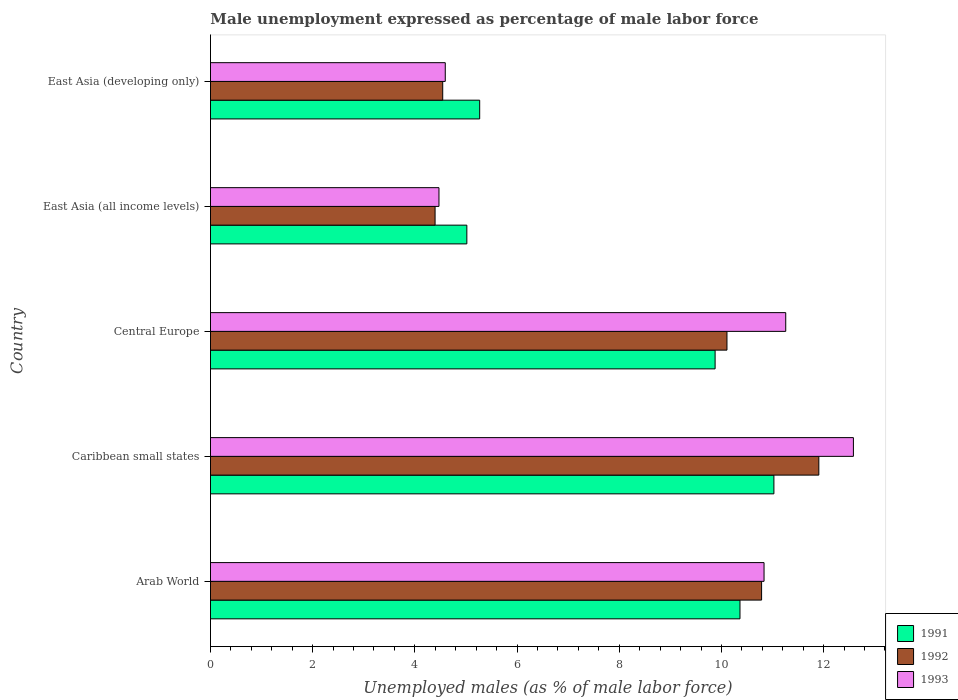Are the number of bars on each tick of the Y-axis equal?
Offer a very short reply. Yes. How many bars are there on the 4th tick from the top?
Give a very brief answer. 3. How many bars are there on the 4th tick from the bottom?
Ensure brevity in your answer.  3. What is the label of the 1st group of bars from the top?
Ensure brevity in your answer.  East Asia (developing only). What is the unemployment in males in in 1992 in East Asia (developing only)?
Provide a succinct answer. 4.55. Across all countries, what is the maximum unemployment in males in in 1992?
Provide a succinct answer. 11.91. Across all countries, what is the minimum unemployment in males in in 1992?
Your answer should be very brief. 4.4. In which country was the unemployment in males in in 1992 maximum?
Offer a very short reply. Caribbean small states. In which country was the unemployment in males in in 1991 minimum?
Make the answer very short. East Asia (all income levels). What is the total unemployment in males in in 1993 in the graph?
Your answer should be very brief. 43.74. What is the difference between the unemployment in males in in 1993 in Arab World and that in East Asia (all income levels)?
Provide a short and direct response. 6.36. What is the difference between the unemployment in males in in 1991 in Caribbean small states and the unemployment in males in in 1993 in East Asia (all income levels)?
Keep it short and to the point. 6.55. What is the average unemployment in males in in 1993 per country?
Offer a terse response. 8.75. What is the difference between the unemployment in males in in 1991 and unemployment in males in in 1992 in Arab World?
Offer a very short reply. -0.42. What is the ratio of the unemployment in males in in 1992 in Caribbean small states to that in East Asia (all income levels)?
Your answer should be very brief. 2.71. Is the difference between the unemployment in males in in 1991 in Arab World and Central Europe greater than the difference between the unemployment in males in in 1992 in Arab World and Central Europe?
Make the answer very short. No. What is the difference between the highest and the second highest unemployment in males in in 1993?
Your answer should be compact. 1.32. What is the difference between the highest and the lowest unemployment in males in in 1991?
Offer a terse response. 6.01. In how many countries, is the unemployment in males in in 1991 greater than the average unemployment in males in in 1991 taken over all countries?
Offer a terse response. 3. Is the sum of the unemployment in males in in 1991 in Caribbean small states and East Asia (all income levels) greater than the maximum unemployment in males in in 1992 across all countries?
Your answer should be compact. Yes. What is the difference between two consecutive major ticks on the X-axis?
Keep it short and to the point. 2. Does the graph contain grids?
Your response must be concise. No. What is the title of the graph?
Provide a succinct answer. Male unemployment expressed as percentage of male labor force. What is the label or title of the X-axis?
Ensure brevity in your answer.  Unemployed males (as % of male labor force). What is the Unemployed males (as % of male labor force) in 1991 in Arab World?
Make the answer very short. 10.36. What is the Unemployed males (as % of male labor force) of 1992 in Arab World?
Offer a terse response. 10.79. What is the Unemployed males (as % of male labor force) in 1993 in Arab World?
Ensure brevity in your answer.  10.83. What is the Unemployed males (as % of male labor force) of 1991 in Caribbean small states?
Give a very brief answer. 11.03. What is the Unemployed males (as % of male labor force) in 1992 in Caribbean small states?
Your answer should be very brief. 11.91. What is the Unemployed males (as % of male labor force) of 1993 in Caribbean small states?
Your answer should be very brief. 12.58. What is the Unemployed males (as % of male labor force) of 1991 in Central Europe?
Give a very brief answer. 9.88. What is the Unemployed males (as % of male labor force) in 1992 in Central Europe?
Ensure brevity in your answer.  10.11. What is the Unemployed males (as % of male labor force) in 1993 in Central Europe?
Provide a short and direct response. 11.26. What is the Unemployed males (as % of male labor force) of 1991 in East Asia (all income levels)?
Provide a succinct answer. 5.02. What is the Unemployed males (as % of male labor force) of 1992 in East Asia (all income levels)?
Your answer should be very brief. 4.4. What is the Unemployed males (as % of male labor force) of 1993 in East Asia (all income levels)?
Your answer should be very brief. 4.47. What is the Unemployed males (as % of male labor force) in 1991 in East Asia (developing only)?
Provide a succinct answer. 5.27. What is the Unemployed males (as % of male labor force) of 1992 in East Asia (developing only)?
Keep it short and to the point. 4.55. What is the Unemployed males (as % of male labor force) of 1993 in East Asia (developing only)?
Your answer should be very brief. 4.6. Across all countries, what is the maximum Unemployed males (as % of male labor force) in 1991?
Provide a short and direct response. 11.03. Across all countries, what is the maximum Unemployed males (as % of male labor force) of 1992?
Give a very brief answer. 11.91. Across all countries, what is the maximum Unemployed males (as % of male labor force) of 1993?
Offer a terse response. 12.58. Across all countries, what is the minimum Unemployed males (as % of male labor force) of 1991?
Your response must be concise. 5.02. Across all countries, what is the minimum Unemployed males (as % of male labor force) in 1992?
Offer a terse response. 4.4. Across all countries, what is the minimum Unemployed males (as % of male labor force) in 1993?
Make the answer very short. 4.47. What is the total Unemployed males (as % of male labor force) of 1991 in the graph?
Make the answer very short. 41.55. What is the total Unemployed males (as % of male labor force) in 1992 in the graph?
Ensure brevity in your answer.  41.74. What is the total Unemployed males (as % of male labor force) of 1993 in the graph?
Ensure brevity in your answer.  43.74. What is the difference between the Unemployed males (as % of male labor force) in 1991 in Arab World and that in Caribbean small states?
Offer a terse response. -0.66. What is the difference between the Unemployed males (as % of male labor force) of 1992 in Arab World and that in Caribbean small states?
Your answer should be very brief. -1.12. What is the difference between the Unemployed males (as % of male labor force) of 1993 in Arab World and that in Caribbean small states?
Provide a succinct answer. -1.75. What is the difference between the Unemployed males (as % of male labor force) of 1991 in Arab World and that in Central Europe?
Your answer should be compact. 0.49. What is the difference between the Unemployed males (as % of male labor force) of 1992 in Arab World and that in Central Europe?
Offer a very short reply. 0.68. What is the difference between the Unemployed males (as % of male labor force) in 1993 in Arab World and that in Central Europe?
Your answer should be very brief. -0.42. What is the difference between the Unemployed males (as % of male labor force) in 1991 in Arab World and that in East Asia (all income levels)?
Make the answer very short. 5.35. What is the difference between the Unemployed males (as % of male labor force) of 1992 in Arab World and that in East Asia (all income levels)?
Provide a short and direct response. 6.39. What is the difference between the Unemployed males (as % of male labor force) of 1993 in Arab World and that in East Asia (all income levels)?
Provide a succinct answer. 6.36. What is the difference between the Unemployed males (as % of male labor force) of 1991 in Arab World and that in East Asia (developing only)?
Offer a very short reply. 5.09. What is the difference between the Unemployed males (as % of male labor force) of 1992 in Arab World and that in East Asia (developing only)?
Ensure brevity in your answer.  6.24. What is the difference between the Unemployed males (as % of male labor force) of 1993 in Arab World and that in East Asia (developing only)?
Your answer should be compact. 6.24. What is the difference between the Unemployed males (as % of male labor force) of 1991 in Caribbean small states and that in Central Europe?
Offer a very short reply. 1.15. What is the difference between the Unemployed males (as % of male labor force) in 1992 in Caribbean small states and that in Central Europe?
Provide a short and direct response. 1.8. What is the difference between the Unemployed males (as % of male labor force) of 1993 in Caribbean small states and that in Central Europe?
Provide a short and direct response. 1.32. What is the difference between the Unemployed males (as % of male labor force) of 1991 in Caribbean small states and that in East Asia (all income levels)?
Ensure brevity in your answer.  6.01. What is the difference between the Unemployed males (as % of male labor force) of 1992 in Caribbean small states and that in East Asia (all income levels)?
Your answer should be very brief. 7.51. What is the difference between the Unemployed males (as % of male labor force) of 1993 in Caribbean small states and that in East Asia (all income levels)?
Make the answer very short. 8.11. What is the difference between the Unemployed males (as % of male labor force) in 1991 in Caribbean small states and that in East Asia (developing only)?
Your answer should be compact. 5.76. What is the difference between the Unemployed males (as % of male labor force) of 1992 in Caribbean small states and that in East Asia (developing only)?
Your answer should be very brief. 7.36. What is the difference between the Unemployed males (as % of male labor force) in 1993 in Caribbean small states and that in East Asia (developing only)?
Make the answer very short. 7.99. What is the difference between the Unemployed males (as % of male labor force) in 1991 in Central Europe and that in East Asia (all income levels)?
Provide a short and direct response. 4.86. What is the difference between the Unemployed males (as % of male labor force) of 1992 in Central Europe and that in East Asia (all income levels)?
Keep it short and to the point. 5.71. What is the difference between the Unemployed males (as % of male labor force) of 1993 in Central Europe and that in East Asia (all income levels)?
Provide a short and direct response. 6.79. What is the difference between the Unemployed males (as % of male labor force) in 1991 in Central Europe and that in East Asia (developing only)?
Offer a terse response. 4.61. What is the difference between the Unemployed males (as % of male labor force) in 1992 in Central Europe and that in East Asia (developing only)?
Your response must be concise. 5.56. What is the difference between the Unemployed males (as % of male labor force) of 1993 in Central Europe and that in East Asia (developing only)?
Provide a succinct answer. 6.66. What is the difference between the Unemployed males (as % of male labor force) in 1991 in East Asia (all income levels) and that in East Asia (developing only)?
Offer a terse response. -0.25. What is the difference between the Unemployed males (as % of male labor force) of 1992 in East Asia (all income levels) and that in East Asia (developing only)?
Offer a very short reply. -0.15. What is the difference between the Unemployed males (as % of male labor force) in 1993 in East Asia (all income levels) and that in East Asia (developing only)?
Your response must be concise. -0.12. What is the difference between the Unemployed males (as % of male labor force) in 1991 in Arab World and the Unemployed males (as % of male labor force) in 1992 in Caribbean small states?
Offer a very short reply. -1.54. What is the difference between the Unemployed males (as % of male labor force) in 1991 in Arab World and the Unemployed males (as % of male labor force) in 1993 in Caribbean small states?
Offer a terse response. -2.22. What is the difference between the Unemployed males (as % of male labor force) in 1992 in Arab World and the Unemployed males (as % of male labor force) in 1993 in Caribbean small states?
Your response must be concise. -1.8. What is the difference between the Unemployed males (as % of male labor force) in 1991 in Arab World and the Unemployed males (as % of male labor force) in 1992 in Central Europe?
Your response must be concise. 0.25. What is the difference between the Unemployed males (as % of male labor force) of 1991 in Arab World and the Unemployed males (as % of male labor force) of 1993 in Central Europe?
Your answer should be compact. -0.9. What is the difference between the Unemployed males (as % of male labor force) in 1992 in Arab World and the Unemployed males (as % of male labor force) in 1993 in Central Europe?
Your answer should be compact. -0.47. What is the difference between the Unemployed males (as % of male labor force) in 1991 in Arab World and the Unemployed males (as % of male labor force) in 1992 in East Asia (all income levels)?
Give a very brief answer. 5.97. What is the difference between the Unemployed males (as % of male labor force) in 1991 in Arab World and the Unemployed males (as % of male labor force) in 1993 in East Asia (all income levels)?
Your answer should be very brief. 5.89. What is the difference between the Unemployed males (as % of male labor force) in 1992 in Arab World and the Unemployed males (as % of male labor force) in 1993 in East Asia (all income levels)?
Give a very brief answer. 6.31. What is the difference between the Unemployed males (as % of male labor force) in 1991 in Arab World and the Unemployed males (as % of male labor force) in 1992 in East Asia (developing only)?
Provide a short and direct response. 5.82. What is the difference between the Unemployed males (as % of male labor force) in 1991 in Arab World and the Unemployed males (as % of male labor force) in 1993 in East Asia (developing only)?
Give a very brief answer. 5.77. What is the difference between the Unemployed males (as % of male labor force) in 1992 in Arab World and the Unemployed males (as % of male labor force) in 1993 in East Asia (developing only)?
Your response must be concise. 6.19. What is the difference between the Unemployed males (as % of male labor force) of 1991 in Caribbean small states and the Unemployed males (as % of male labor force) of 1992 in Central Europe?
Provide a succinct answer. 0.92. What is the difference between the Unemployed males (as % of male labor force) of 1991 in Caribbean small states and the Unemployed males (as % of male labor force) of 1993 in Central Europe?
Keep it short and to the point. -0.23. What is the difference between the Unemployed males (as % of male labor force) in 1992 in Caribbean small states and the Unemployed males (as % of male labor force) in 1993 in Central Europe?
Provide a short and direct response. 0.65. What is the difference between the Unemployed males (as % of male labor force) in 1991 in Caribbean small states and the Unemployed males (as % of male labor force) in 1992 in East Asia (all income levels)?
Your response must be concise. 6.63. What is the difference between the Unemployed males (as % of male labor force) in 1991 in Caribbean small states and the Unemployed males (as % of male labor force) in 1993 in East Asia (all income levels)?
Give a very brief answer. 6.55. What is the difference between the Unemployed males (as % of male labor force) of 1992 in Caribbean small states and the Unemployed males (as % of male labor force) of 1993 in East Asia (all income levels)?
Your response must be concise. 7.43. What is the difference between the Unemployed males (as % of male labor force) of 1991 in Caribbean small states and the Unemployed males (as % of male labor force) of 1992 in East Asia (developing only)?
Provide a short and direct response. 6.48. What is the difference between the Unemployed males (as % of male labor force) of 1991 in Caribbean small states and the Unemployed males (as % of male labor force) of 1993 in East Asia (developing only)?
Offer a very short reply. 6.43. What is the difference between the Unemployed males (as % of male labor force) in 1992 in Caribbean small states and the Unemployed males (as % of male labor force) in 1993 in East Asia (developing only)?
Give a very brief answer. 7.31. What is the difference between the Unemployed males (as % of male labor force) in 1991 in Central Europe and the Unemployed males (as % of male labor force) in 1992 in East Asia (all income levels)?
Ensure brevity in your answer.  5.48. What is the difference between the Unemployed males (as % of male labor force) of 1991 in Central Europe and the Unemployed males (as % of male labor force) of 1993 in East Asia (all income levels)?
Offer a very short reply. 5.4. What is the difference between the Unemployed males (as % of male labor force) of 1992 in Central Europe and the Unemployed males (as % of male labor force) of 1993 in East Asia (all income levels)?
Your answer should be compact. 5.64. What is the difference between the Unemployed males (as % of male labor force) in 1991 in Central Europe and the Unemployed males (as % of male labor force) in 1992 in East Asia (developing only)?
Keep it short and to the point. 5.33. What is the difference between the Unemployed males (as % of male labor force) in 1991 in Central Europe and the Unemployed males (as % of male labor force) in 1993 in East Asia (developing only)?
Offer a very short reply. 5.28. What is the difference between the Unemployed males (as % of male labor force) in 1992 in Central Europe and the Unemployed males (as % of male labor force) in 1993 in East Asia (developing only)?
Your answer should be very brief. 5.51. What is the difference between the Unemployed males (as % of male labor force) of 1991 in East Asia (all income levels) and the Unemployed males (as % of male labor force) of 1992 in East Asia (developing only)?
Make the answer very short. 0.47. What is the difference between the Unemployed males (as % of male labor force) of 1991 in East Asia (all income levels) and the Unemployed males (as % of male labor force) of 1993 in East Asia (developing only)?
Your answer should be compact. 0.42. What is the difference between the Unemployed males (as % of male labor force) in 1992 in East Asia (all income levels) and the Unemployed males (as % of male labor force) in 1993 in East Asia (developing only)?
Provide a short and direct response. -0.2. What is the average Unemployed males (as % of male labor force) of 1991 per country?
Give a very brief answer. 8.31. What is the average Unemployed males (as % of male labor force) in 1992 per country?
Your answer should be compact. 8.35. What is the average Unemployed males (as % of male labor force) in 1993 per country?
Offer a terse response. 8.75. What is the difference between the Unemployed males (as % of male labor force) in 1991 and Unemployed males (as % of male labor force) in 1992 in Arab World?
Offer a very short reply. -0.42. What is the difference between the Unemployed males (as % of male labor force) of 1991 and Unemployed males (as % of male labor force) of 1993 in Arab World?
Your answer should be very brief. -0.47. What is the difference between the Unemployed males (as % of male labor force) of 1992 and Unemployed males (as % of male labor force) of 1993 in Arab World?
Offer a terse response. -0.05. What is the difference between the Unemployed males (as % of male labor force) in 1991 and Unemployed males (as % of male labor force) in 1992 in Caribbean small states?
Your answer should be very brief. -0.88. What is the difference between the Unemployed males (as % of male labor force) in 1991 and Unemployed males (as % of male labor force) in 1993 in Caribbean small states?
Give a very brief answer. -1.56. What is the difference between the Unemployed males (as % of male labor force) of 1992 and Unemployed males (as % of male labor force) of 1993 in Caribbean small states?
Offer a very short reply. -0.68. What is the difference between the Unemployed males (as % of male labor force) in 1991 and Unemployed males (as % of male labor force) in 1992 in Central Europe?
Your answer should be compact. -0.23. What is the difference between the Unemployed males (as % of male labor force) of 1991 and Unemployed males (as % of male labor force) of 1993 in Central Europe?
Your answer should be very brief. -1.38. What is the difference between the Unemployed males (as % of male labor force) of 1992 and Unemployed males (as % of male labor force) of 1993 in Central Europe?
Offer a very short reply. -1.15. What is the difference between the Unemployed males (as % of male labor force) of 1991 and Unemployed males (as % of male labor force) of 1992 in East Asia (all income levels)?
Provide a succinct answer. 0.62. What is the difference between the Unemployed males (as % of male labor force) of 1991 and Unemployed males (as % of male labor force) of 1993 in East Asia (all income levels)?
Give a very brief answer. 0.55. What is the difference between the Unemployed males (as % of male labor force) of 1992 and Unemployed males (as % of male labor force) of 1993 in East Asia (all income levels)?
Offer a terse response. -0.08. What is the difference between the Unemployed males (as % of male labor force) of 1991 and Unemployed males (as % of male labor force) of 1992 in East Asia (developing only)?
Give a very brief answer. 0.72. What is the difference between the Unemployed males (as % of male labor force) in 1991 and Unemployed males (as % of male labor force) in 1993 in East Asia (developing only)?
Ensure brevity in your answer.  0.67. What is the difference between the Unemployed males (as % of male labor force) of 1992 and Unemployed males (as % of male labor force) of 1993 in East Asia (developing only)?
Your response must be concise. -0.05. What is the ratio of the Unemployed males (as % of male labor force) in 1991 in Arab World to that in Caribbean small states?
Provide a succinct answer. 0.94. What is the ratio of the Unemployed males (as % of male labor force) in 1992 in Arab World to that in Caribbean small states?
Provide a succinct answer. 0.91. What is the ratio of the Unemployed males (as % of male labor force) of 1993 in Arab World to that in Caribbean small states?
Ensure brevity in your answer.  0.86. What is the ratio of the Unemployed males (as % of male labor force) of 1991 in Arab World to that in Central Europe?
Ensure brevity in your answer.  1.05. What is the ratio of the Unemployed males (as % of male labor force) of 1992 in Arab World to that in Central Europe?
Offer a terse response. 1.07. What is the ratio of the Unemployed males (as % of male labor force) of 1993 in Arab World to that in Central Europe?
Provide a succinct answer. 0.96. What is the ratio of the Unemployed males (as % of male labor force) of 1991 in Arab World to that in East Asia (all income levels)?
Your response must be concise. 2.07. What is the ratio of the Unemployed males (as % of male labor force) in 1992 in Arab World to that in East Asia (all income levels)?
Provide a succinct answer. 2.45. What is the ratio of the Unemployed males (as % of male labor force) in 1993 in Arab World to that in East Asia (all income levels)?
Your answer should be very brief. 2.42. What is the ratio of the Unemployed males (as % of male labor force) in 1991 in Arab World to that in East Asia (developing only)?
Offer a terse response. 1.97. What is the ratio of the Unemployed males (as % of male labor force) in 1992 in Arab World to that in East Asia (developing only)?
Keep it short and to the point. 2.37. What is the ratio of the Unemployed males (as % of male labor force) in 1993 in Arab World to that in East Asia (developing only)?
Your answer should be compact. 2.36. What is the ratio of the Unemployed males (as % of male labor force) in 1991 in Caribbean small states to that in Central Europe?
Make the answer very short. 1.12. What is the ratio of the Unemployed males (as % of male labor force) in 1992 in Caribbean small states to that in Central Europe?
Your answer should be compact. 1.18. What is the ratio of the Unemployed males (as % of male labor force) of 1993 in Caribbean small states to that in Central Europe?
Keep it short and to the point. 1.12. What is the ratio of the Unemployed males (as % of male labor force) in 1991 in Caribbean small states to that in East Asia (all income levels)?
Offer a very short reply. 2.2. What is the ratio of the Unemployed males (as % of male labor force) in 1992 in Caribbean small states to that in East Asia (all income levels)?
Provide a short and direct response. 2.71. What is the ratio of the Unemployed males (as % of male labor force) of 1993 in Caribbean small states to that in East Asia (all income levels)?
Make the answer very short. 2.81. What is the ratio of the Unemployed males (as % of male labor force) of 1991 in Caribbean small states to that in East Asia (developing only)?
Provide a succinct answer. 2.09. What is the ratio of the Unemployed males (as % of male labor force) of 1992 in Caribbean small states to that in East Asia (developing only)?
Offer a very short reply. 2.62. What is the ratio of the Unemployed males (as % of male labor force) of 1993 in Caribbean small states to that in East Asia (developing only)?
Ensure brevity in your answer.  2.74. What is the ratio of the Unemployed males (as % of male labor force) of 1991 in Central Europe to that in East Asia (all income levels)?
Make the answer very short. 1.97. What is the ratio of the Unemployed males (as % of male labor force) of 1992 in Central Europe to that in East Asia (all income levels)?
Provide a short and direct response. 2.3. What is the ratio of the Unemployed males (as % of male labor force) in 1993 in Central Europe to that in East Asia (all income levels)?
Your answer should be compact. 2.52. What is the ratio of the Unemployed males (as % of male labor force) in 1991 in Central Europe to that in East Asia (developing only)?
Ensure brevity in your answer.  1.87. What is the ratio of the Unemployed males (as % of male labor force) of 1992 in Central Europe to that in East Asia (developing only)?
Provide a short and direct response. 2.22. What is the ratio of the Unemployed males (as % of male labor force) of 1993 in Central Europe to that in East Asia (developing only)?
Offer a terse response. 2.45. What is the ratio of the Unemployed males (as % of male labor force) of 1991 in East Asia (all income levels) to that in East Asia (developing only)?
Make the answer very short. 0.95. What is the ratio of the Unemployed males (as % of male labor force) of 1992 in East Asia (all income levels) to that in East Asia (developing only)?
Offer a terse response. 0.97. What is the ratio of the Unemployed males (as % of male labor force) of 1993 in East Asia (all income levels) to that in East Asia (developing only)?
Make the answer very short. 0.97. What is the difference between the highest and the second highest Unemployed males (as % of male labor force) in 1991?
Offer a very short reply. 0.66. What is the difference between the highest and the second highest Unemployed males (as % of male labor force) of 1992?
Offer a terse response. 1.12. What is the difference between the highest and the second highest Unemployed males (as % of male labor force) of 1993?
Give a very brief answer. 1.32. What is the difference between the highest and the lowest Unemployed males (as % of male labor force) in 1991?
Your answer should be compact. 6.01. What is the difference between the highest and the lowest Unemployed males (as % of male labor force) of 1992?
Offer a terse response. 7.51. What is the difference between the highest and the lowest Unemployed males (as % of male labor force) in 1993?
Ensure brevity in your answer.  8.11. 